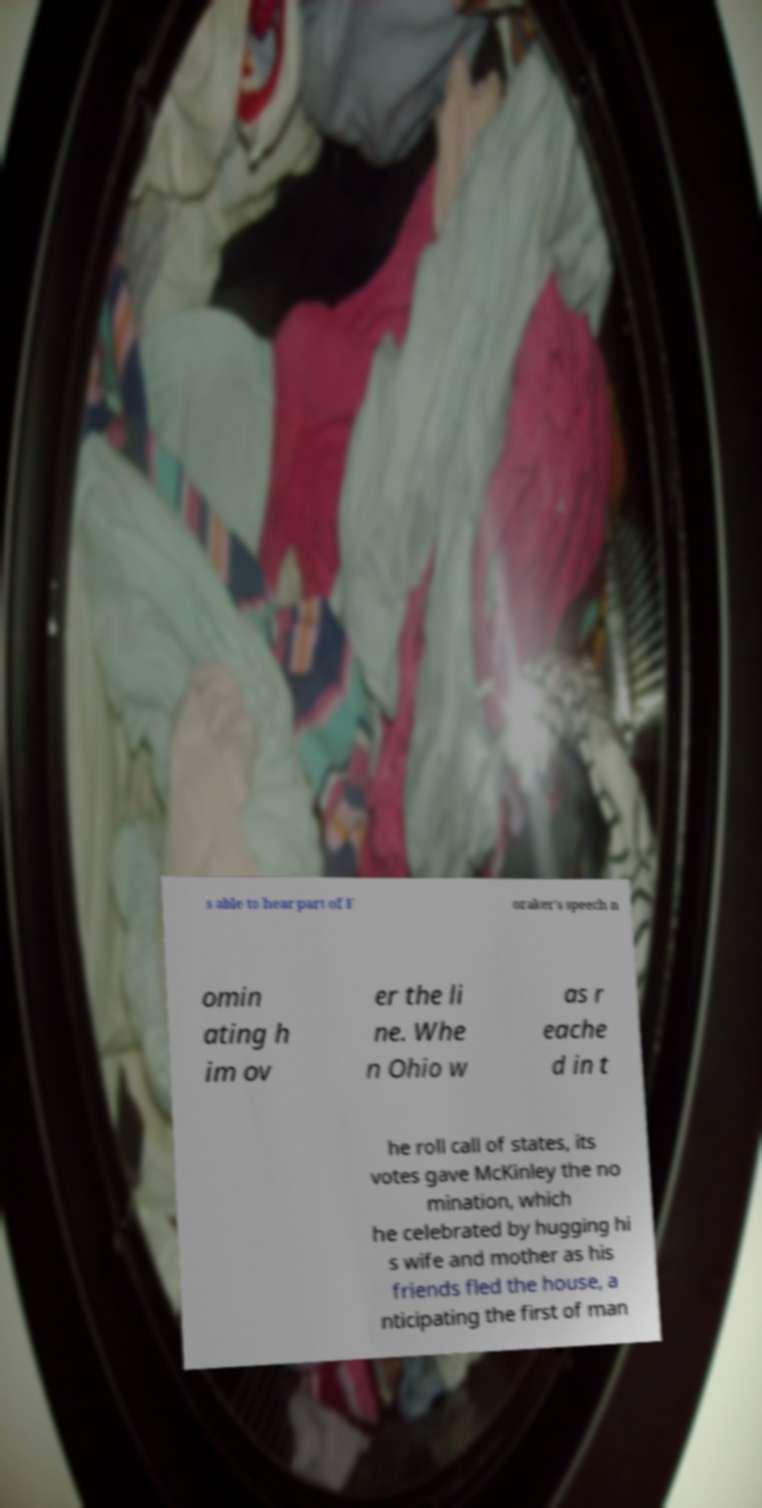Can you read and provide the text displayed in the image?This photo seems to have some interesting text. Can you extract and type it out for me? s able to hear part of F oraker's speech n omin ating h im ov er the li ne. Whe n Ohio w as r eache d in t he roll call of states, its votes gave McKinley the no mination, which he celebrated by hugging hi s wife and mother as his friends fled the house, a nticipating the first of man 